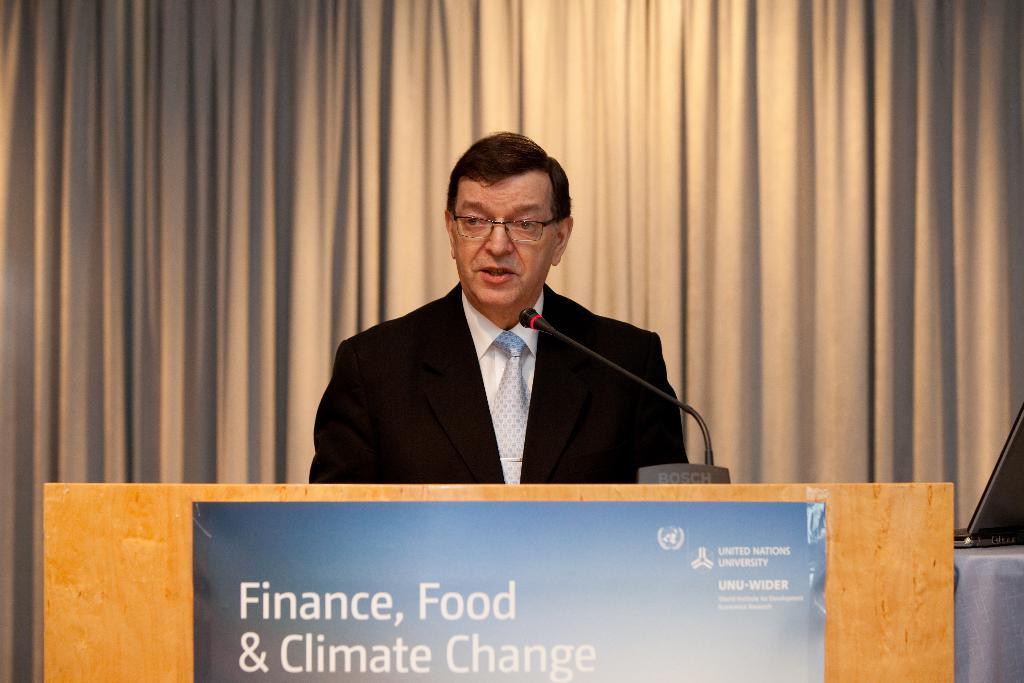What is the person on the podium doing? The person is standing on the podium. What object is on the podium with the person? There is a microphone on the podium. What is displayed on the podium? There is a banner on the podium. What can be seen behind the person on the podium? There is a curtain behind the person. What type of animals can be seen in the zoo in the image? There is no zoo present in the image; it features a person standing on a podium with a microphone, banner, and curtain. 